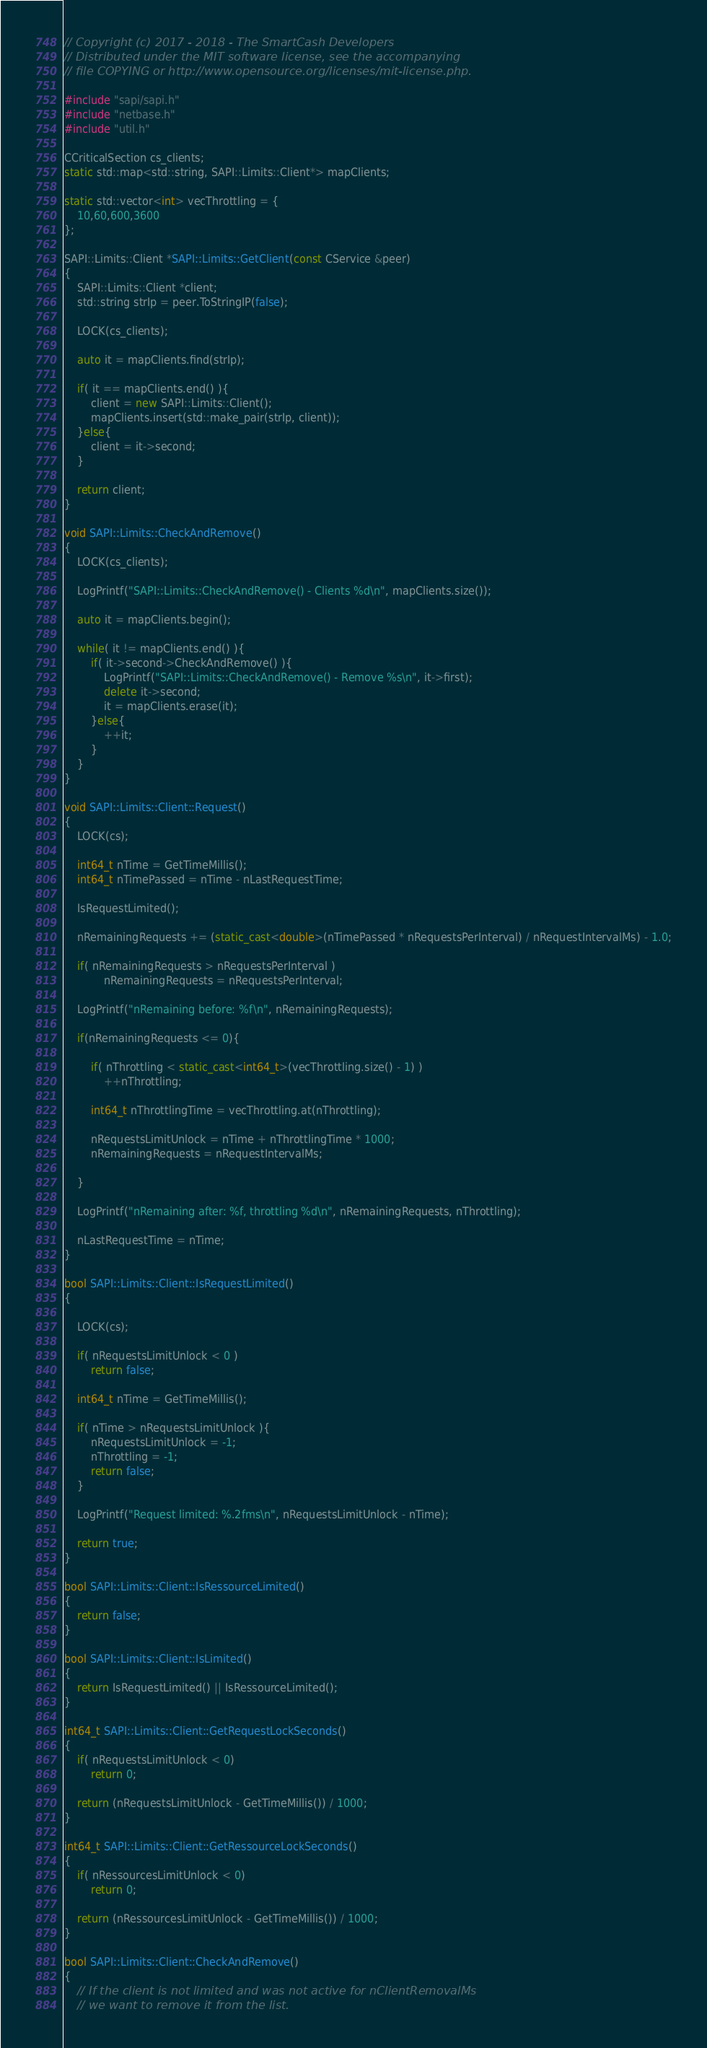Convert code to text. <code><loc_0><loc_0><loc_500><loc_500><_C++_>// Copyright (c) 2017 - 2018 - The SmartCash Developers
// Distributed under the MIT software license, see the accompanying
// file COPYING or http://www.opensource.org/licenses/mit-license.php.

#include "sapi/sapi.h"
#include "netbase.h"
#include "util.h"

CCriticalSection cs_clients;
static std::map<std::string, SAPI::Limits::Client*> mapClients;

static std::vector<int> vecThrottling = {
    10,60,600,3600
};

SAPI::Limits::Client *SAPI::Limits::GetClient(const CService &peer)
{
    SAPI::Limits::Client *client;
    std::string strIp = peer.ToStringIP(false);

    LOCK(cs_clients);

    auto it = mapClients.find(strIp);

    if( it == mapClients.end() ){
        client = new SAPI::Limits::Client();
        mapClients.insert(std::make_pair(strIp, client));
    }else{
        client = it->second;
    }

    return client;
}

void SAPI::Limits::CheckAndRemove()
{
    LOCK(cs_clients);

    LogPrintf("SAPI::Limits::CheckAndRemove() - Clients %d\n", mapClients.size());

    auto it = mapClients.begin();

    while( it != mapClients.end() ){
        if( it->second->CheckAndRemove() ){
            LogPrintf("SAPI::Limits::CheckAndRemove() - Remove %s\n", it->first);
            delete it->second;
            it = mapClients.erase(it);
        }else{
            ++it;
        }
    }
}

void SAPI::Limits::Client::Request()
{
    LOCK(cs);

    int64_t nTime = GetTimeMillis();
    int64_t nTimePassed = nTime - nLastRequestTime;

    IsRequestLimited();

    nRemainingRequests += (static_cast<double>(nTimePassed * nRequestsPerInterval) / nRequestIntervalMs) - 1.0;

    if( nRemainingRequests > nRequestsPerInterval )
            nRemainingRequests = nRequestsPerInterval;

    LogPrintf("nRemaining before: %f\n", nRemainingRequests);

    if(nRemainingRequests <= 0){

        if( nThrottling < static_cast<int64_t>(vecThrottling.size() - 1) )
            ++nThrottling;

        int64_t nThrottlingTime = vecThrottling.at(nThrottling);

        nRequestsLimitUnlock = nTime + nThrottlingTime * 1000;
        nRemainingRequests = nRequestIntervalMs;

    }

    LogPrintf("nRemaining after: %f, throttling %d\n", nRemainingRequests, nThrottling);

    nLastRequestTime = nTime;
}

bool SAPI::Limits::Client::IsRequestLimited()
{

    LOCK(cs);

    if( nRequestsLimitUnlock < 0 )
        return false;

    int64_t nTime = GetTimeMillis();

    if( nTime > nRequestsLimitUnlock ){
        nRequestsLimitUnlock = -1;
        nThrottling = -1;
        return false;
    }

    LogPrintf("Request limited: %.2fms\n", nRequestsLimitUnlock - nTime);

    return true;
}

bool SAPI::Limits::Client::IsRessourceLimited()
{
    return false;
}

bool SAPI::Limits::Client::IsLimited()
{
    return IsRequestLimited() || IsRessourceLimited();
}

int64_t SAPI::Limits::Client::GetRequestLockSeconds()
{
    if( nRequestsLimitUnlock < 0)
        return 0;

    return (nRequestsLimitUnlock - GetTimeMillis()) / 1000;
}

int64_t SAPI::Limits::Client::GetRessourceLockSeconds()
{
    if( nRessourcesLimitUnlock < 0)
        return 0;

    return (nRessourcesLimitUnlock - GetTimeMillis()) / 1000;
}

bool SAPI::Limits::Client::CheckAndRemove()
{
    // If the client is not limited and was not active for nClientRemovalMs
    // we want to remove it from the list.</code> 